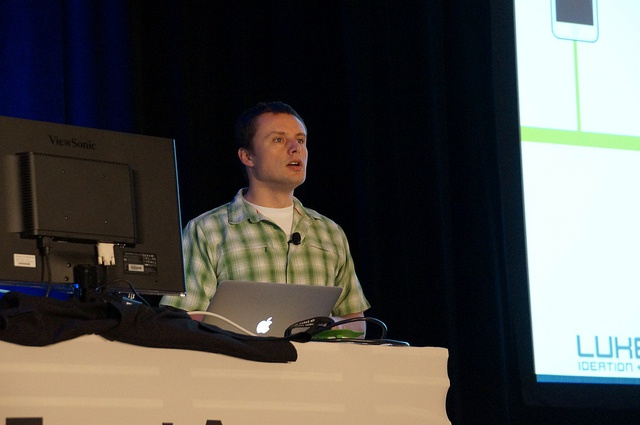Describe the objects in this image and their specific colors. I can see tv in black, white, lightgreen, lightblue, and gray tones, tv in black, tan, and gray tones, people in black, tan, gray, and olive tones, and laptop in black, gray, and tan tones in this image. 